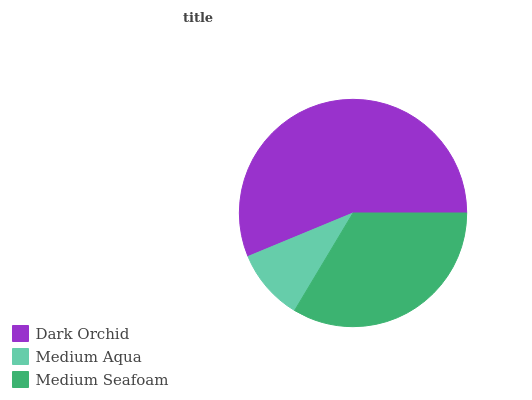Is Medium Aqua the minimum?
Answer yes or no. Yes. Is Dark Orchid the maximum?
Answer yes or no. Yes. Is Medium Seafoam the minimum?
Answer yes or no. No. Is Medium Seafoam the maximum?
Answer yes or no. No. Is Medium Seafoam greater than Medium Aqua?
Answer yes or no. Yes. Is Medium Aqua less than Medium Seafoam?
Answer yes or no. Yes. Is Medium Aqua greater than Medium Seafoam?
Answer yes or no. No. Is Medium Seafoam less than Medium Aqua?
Answer yes or no. No. Is Medium Seafoam the high median?
Answer yes or no. Yes. Is Medium Seafoam the low median?
Answer yes or no. Yes. Is Dark Orchid the high median?
Answer yes or no. No. Is Dark Orchid the low median?
Answer yes or no. No. 